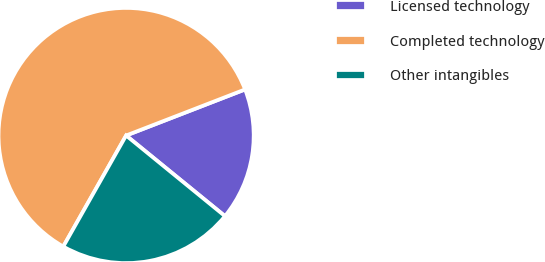Convert chart. <chart><loc_0><loc_0><loc_500><loc_500><pie_chart><fcel>Licensed technology<fcel>Completed technology<fcel>Other intangibles<nl><fcel>16.77%<fcel>60.93%<fcel>22.31%<nl></chart> 